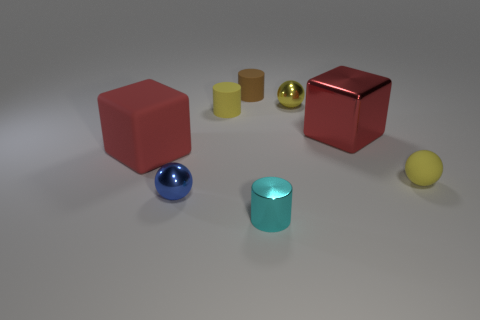Subtract all yellow matte spheres. How many spheres are left? 2 Subtract all yellow blocks. How many yellow spheres are left? 2 Subtract 1 cylinders. How many cylinders are left? 2 Add 1 small cyan metallic things. How many objects exist? 9 Subtract all balls. How many objects are left? 5 Subtract all green balls. Subtract all green cubes. How many balls are left? 3 Subtract all large red metallic blocks. Subtract all small brown matte cylinders. How many objects are left? 6 Add 7 small brown rubber cylinders. How many small brown rubber cylinders are left? 8 Add 3 small red metallic cylinders. How many small red metallic cylinders exist? 3 Subtract 2 red blocks. How many objects are left? 6 